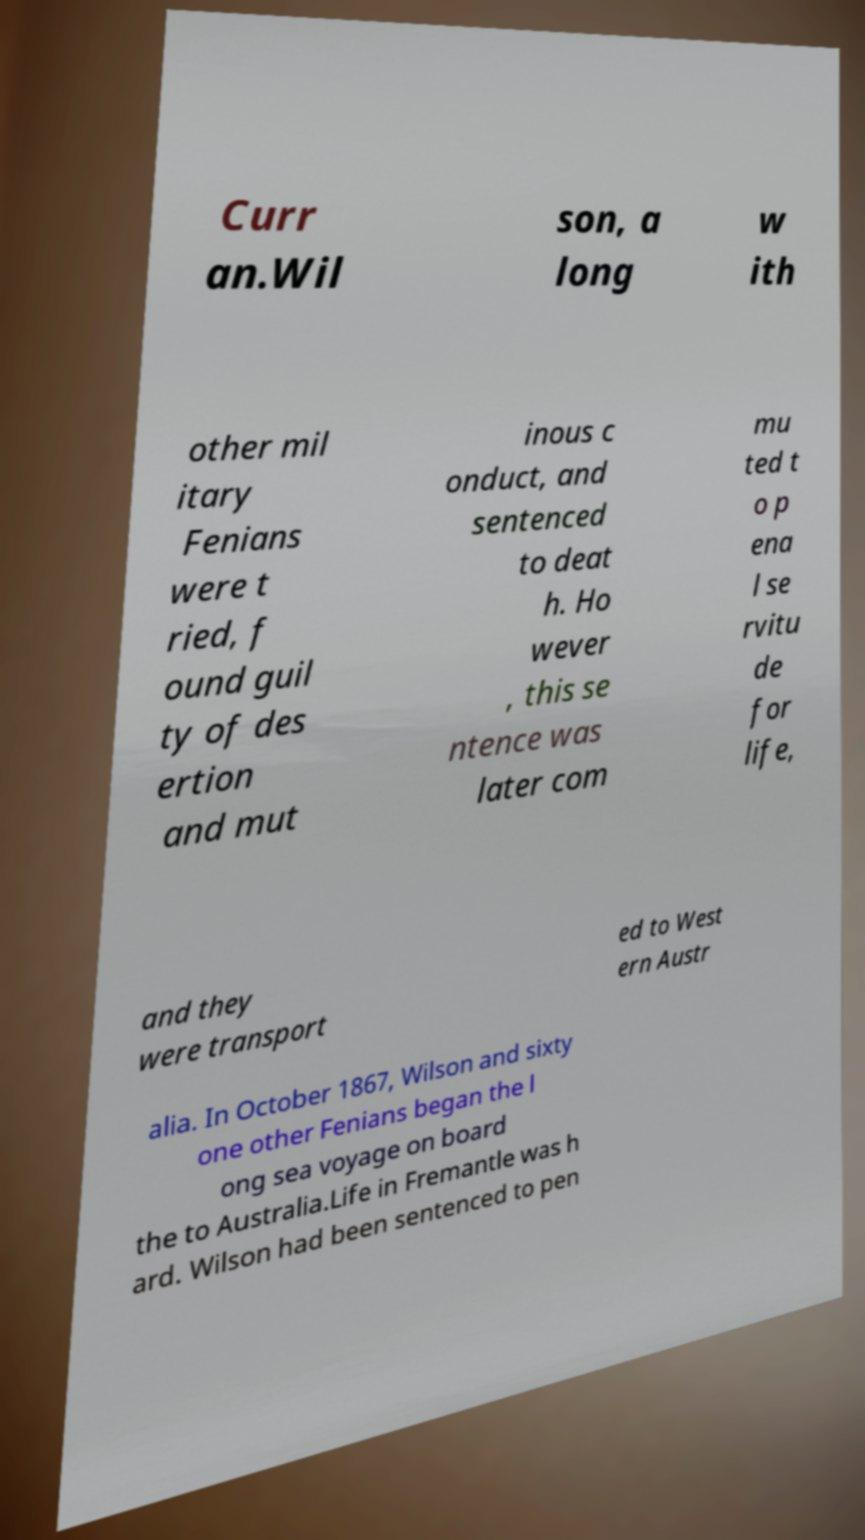I need the written content from this picture converted into text. Can you do that? Curr an.Wil son, a long w ith other mil itary Fenians were t ried, f ound guil ty of des ertion and mut inous c onduct, and sentenced to deat h. Ho wever , this se ntence was later com mu ted t o p ena l se rvitu de for life, and they were transport ed to West ern Austr alia. In October 1867, Wilson and sixty one other Fenians began the l ong sea voyage on board the to Australia.Life in Fremantle was h ard. Wilson had been sentenced to pen 